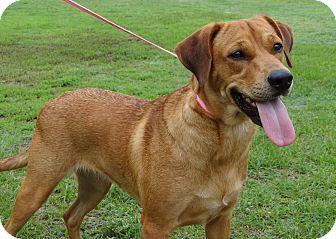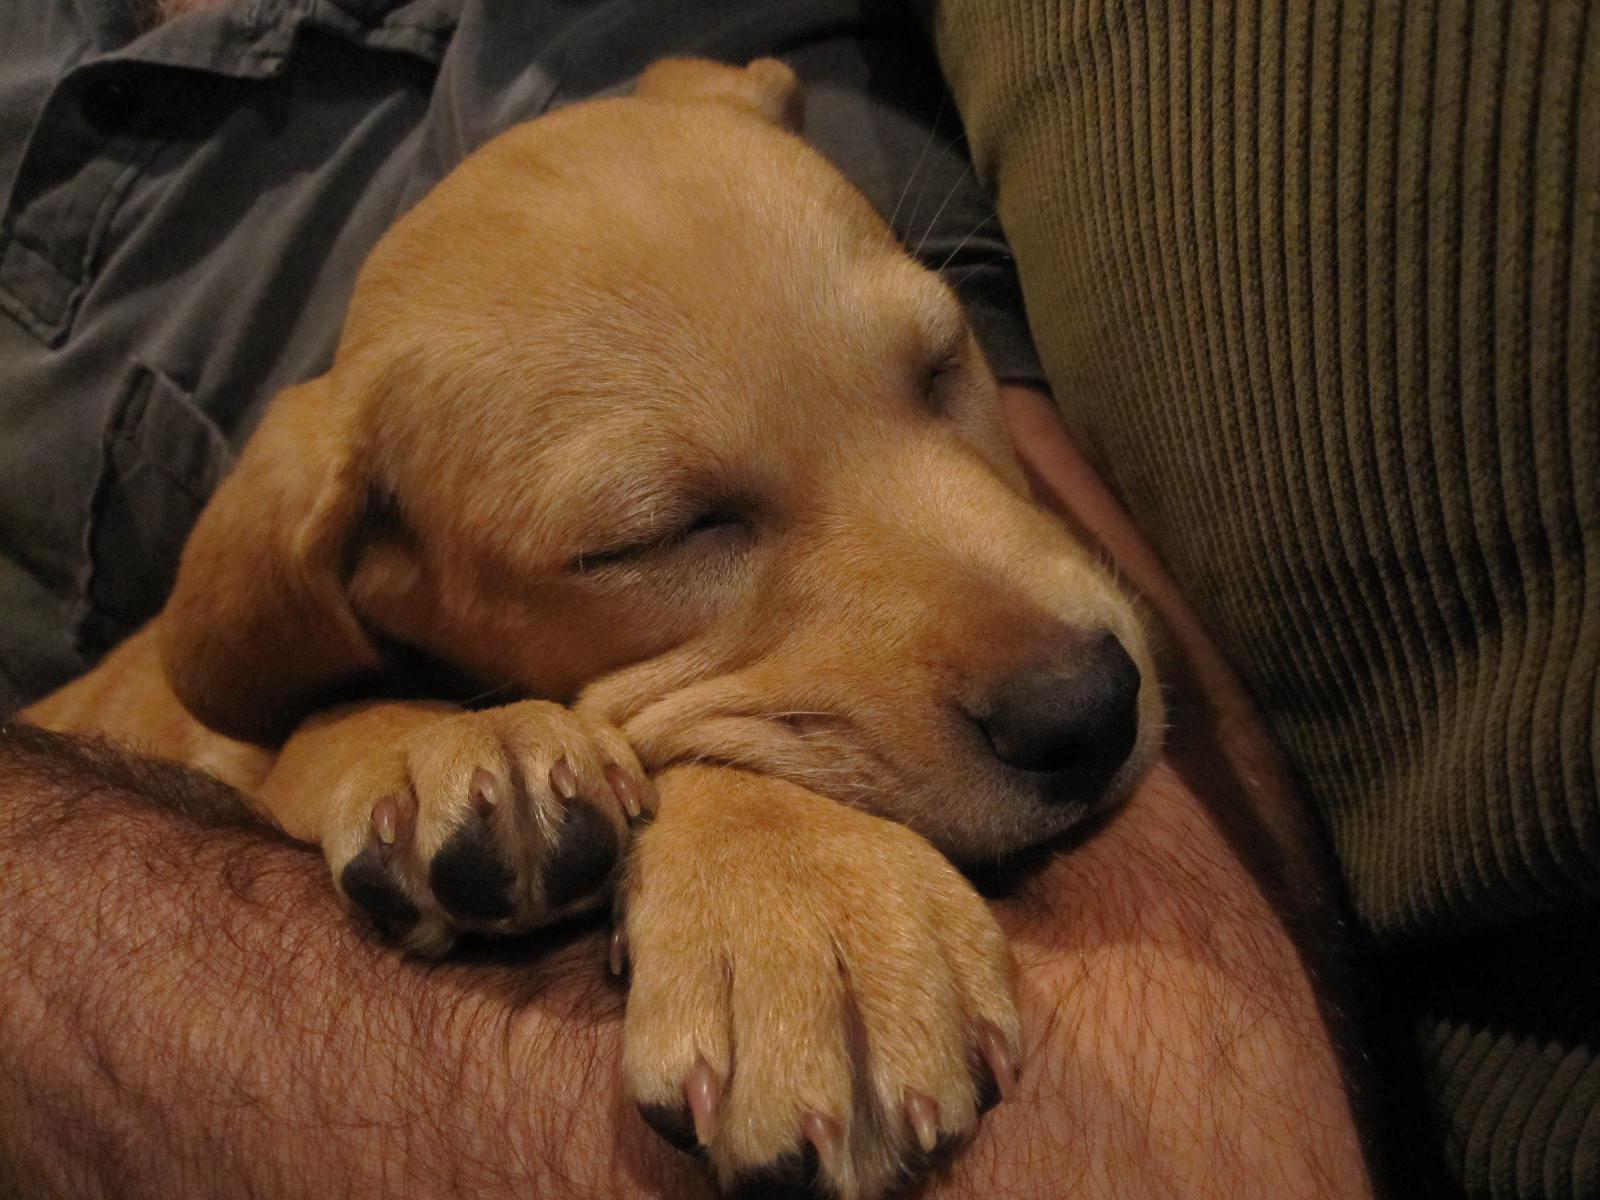The first image is the image on the left, the second image is the image on the right. For the images shown, is this caption "The left image contains at least two dogs." true? Answer yes or no. No. The first image is the image on the left, the second image is the image on the right. Evaluate the accuracy of this statement regarding the images: "The dogs in each of the images are outside.". Is it true? Answer yes or no. No. 